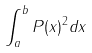<formula> <loc_0><loc_0><loc_500><loc_500>\int _ { a } ^ { b } P ( x ) ^ { 2 } d x</formula> 